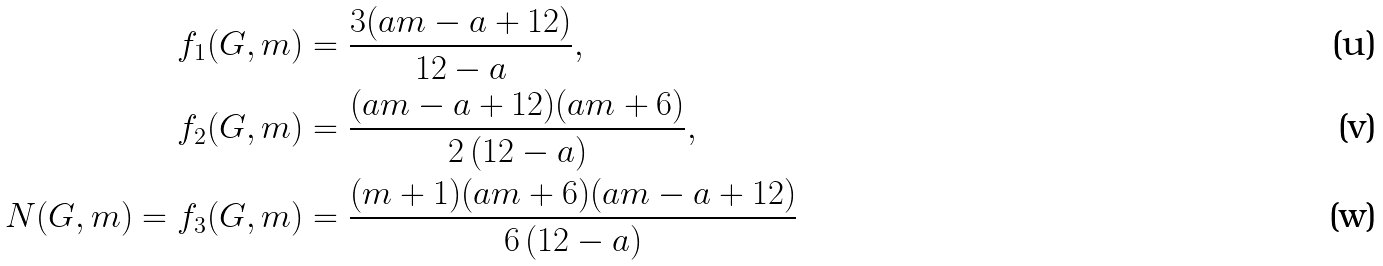<formula> <loc_0><loc_0><loc_500><loc_500>f _ { 1 } ( G , m ) & = \frac { 3 ( a m - a + 1 2 ) } { 1 2 - a } , \\ f _ { 2 } ( G , m ) & = \frac { ( a m - a + 1 2 ) ( a m + 6 ) } { 2 \, ( 1 2 - a ) } , \\ N ( G , m ) = f _ { 3 } ( G , m ) & = \frac { ( m + 1 ) ( a m + 6 ) ( a m - a + 1 2 ) } { 6 \, ( 1 2 - a ) }</formula> 